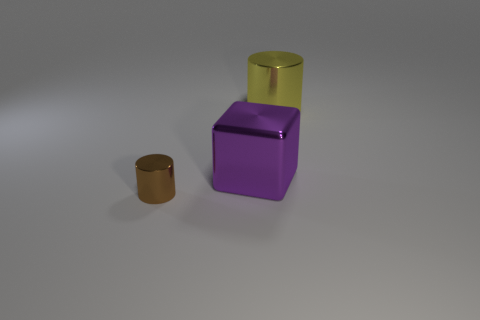Is there a tiny brown metal thing?
Ensure brevity in your answer.  Yes. What is the shape of the thing that is in front of the purple object?
Provide a short and direct response. Cylinder. How many metallic objects are both to the right of the block and in front of the purple shiny block?
Keep it short and to the point. 0. Is there a brown cylinder that has the same material as the big purple object?
Provide a succinct answer. Yes. What number of cylinders are either tiny cyan matte objects or large purple metal objects?
Offer a terse response. 0. The brown cylinder has what size?
Provide a succinct answer. Small. What number of metal cylinders are in front of the brown cylinder?
Your answer should be compact. 0. What is the size of the metal cylinder on the right side of the metallic object that is to the left of the purple shiny thing?
Your response must be concise. Large. Does the big thing behind the purple cube have the same shape as the metal thing in front of the big purple metal cube?
Provide a short and direct response. Yes. What is the shape of the shiny object that is on the right side of the large object to the left of the yellow cylinder?
Ensure brevity in your answer.  Cylinder. 